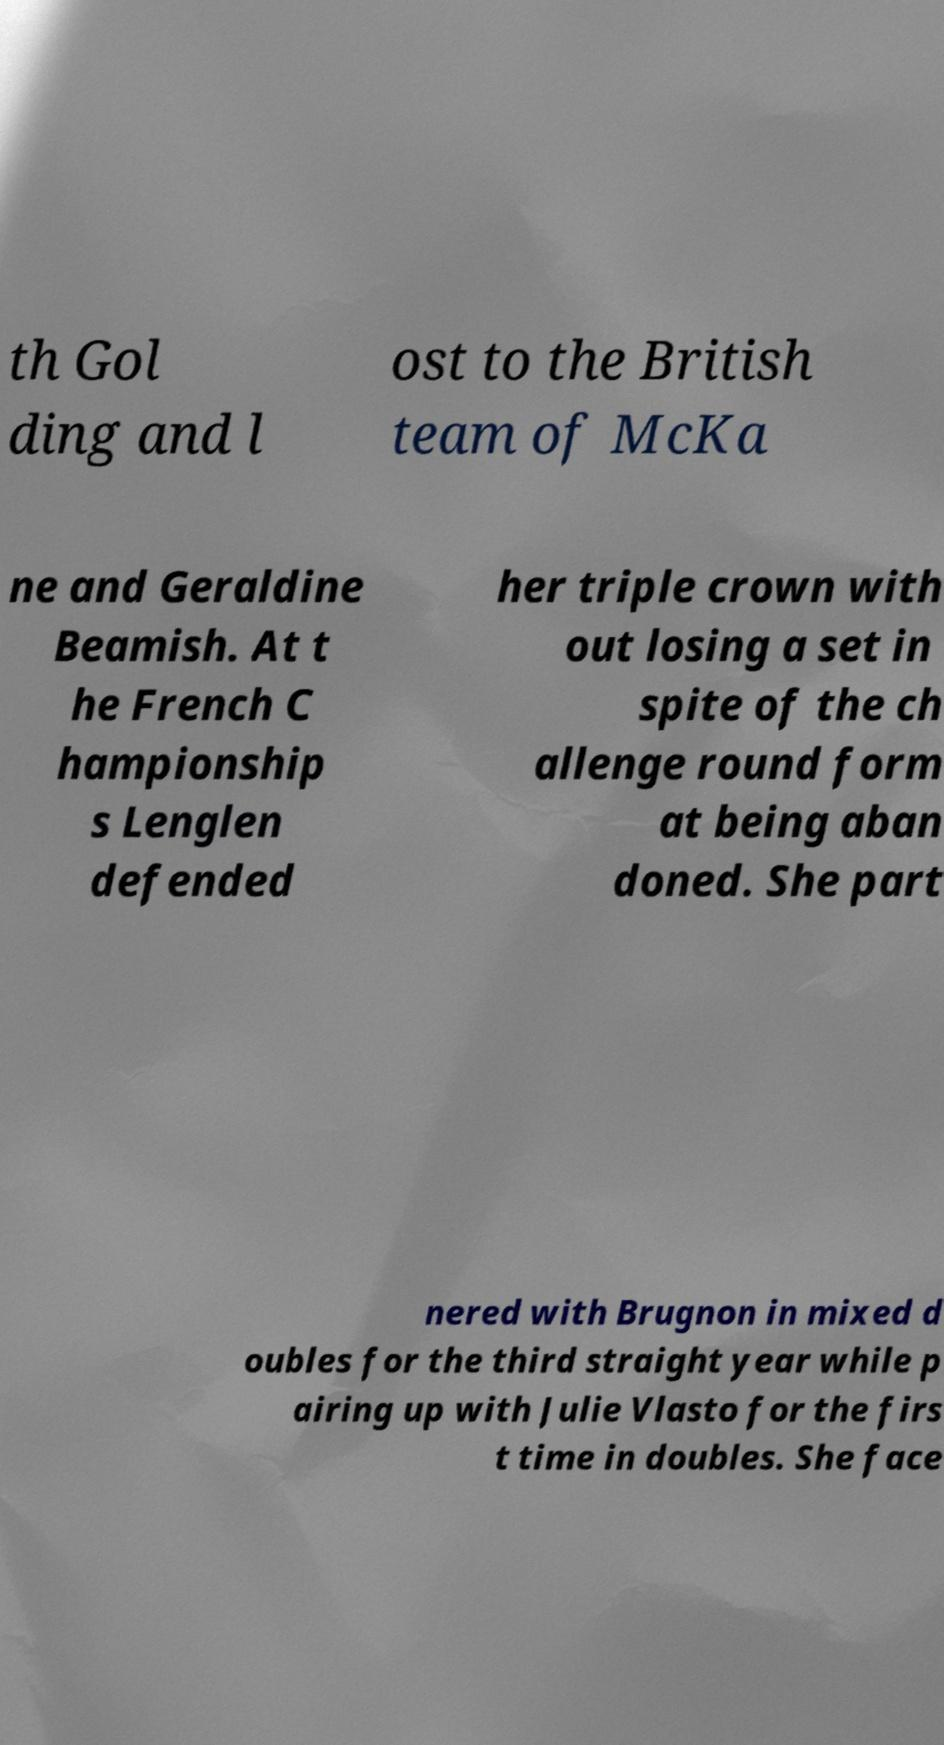Please read and relay the text visible in this image. What does it say? th Gol ding and l ost to the British team of McKa ne and Geraldine Beamish. At t he French C hampionship s Lenglen defended her triple crown with out losing a set in spite of the ch allenge round form at being aban doned. She part nered with Brugnon in mixed d oubles for the third straight year while p airing up with Julie Vlasto for the firs t time in doubles. She face 